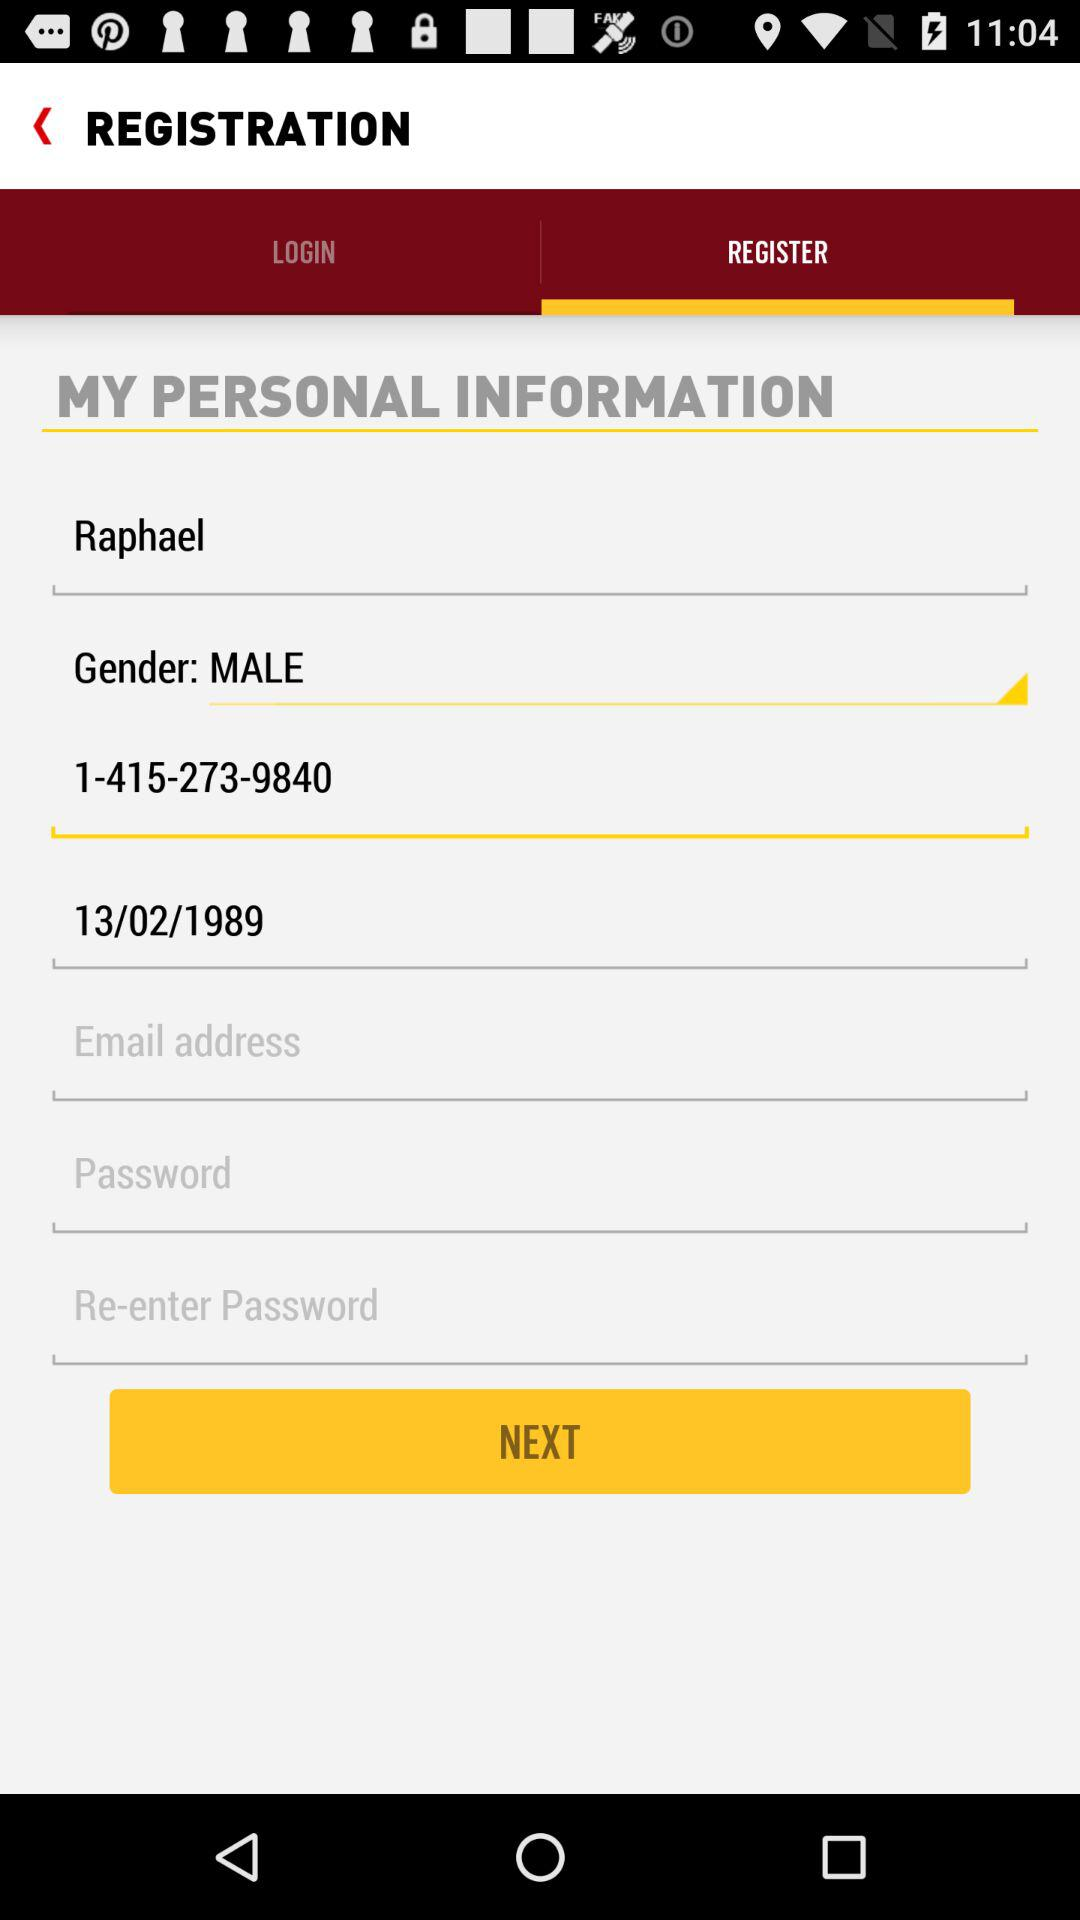What is the user name? The user name is Raphael. 